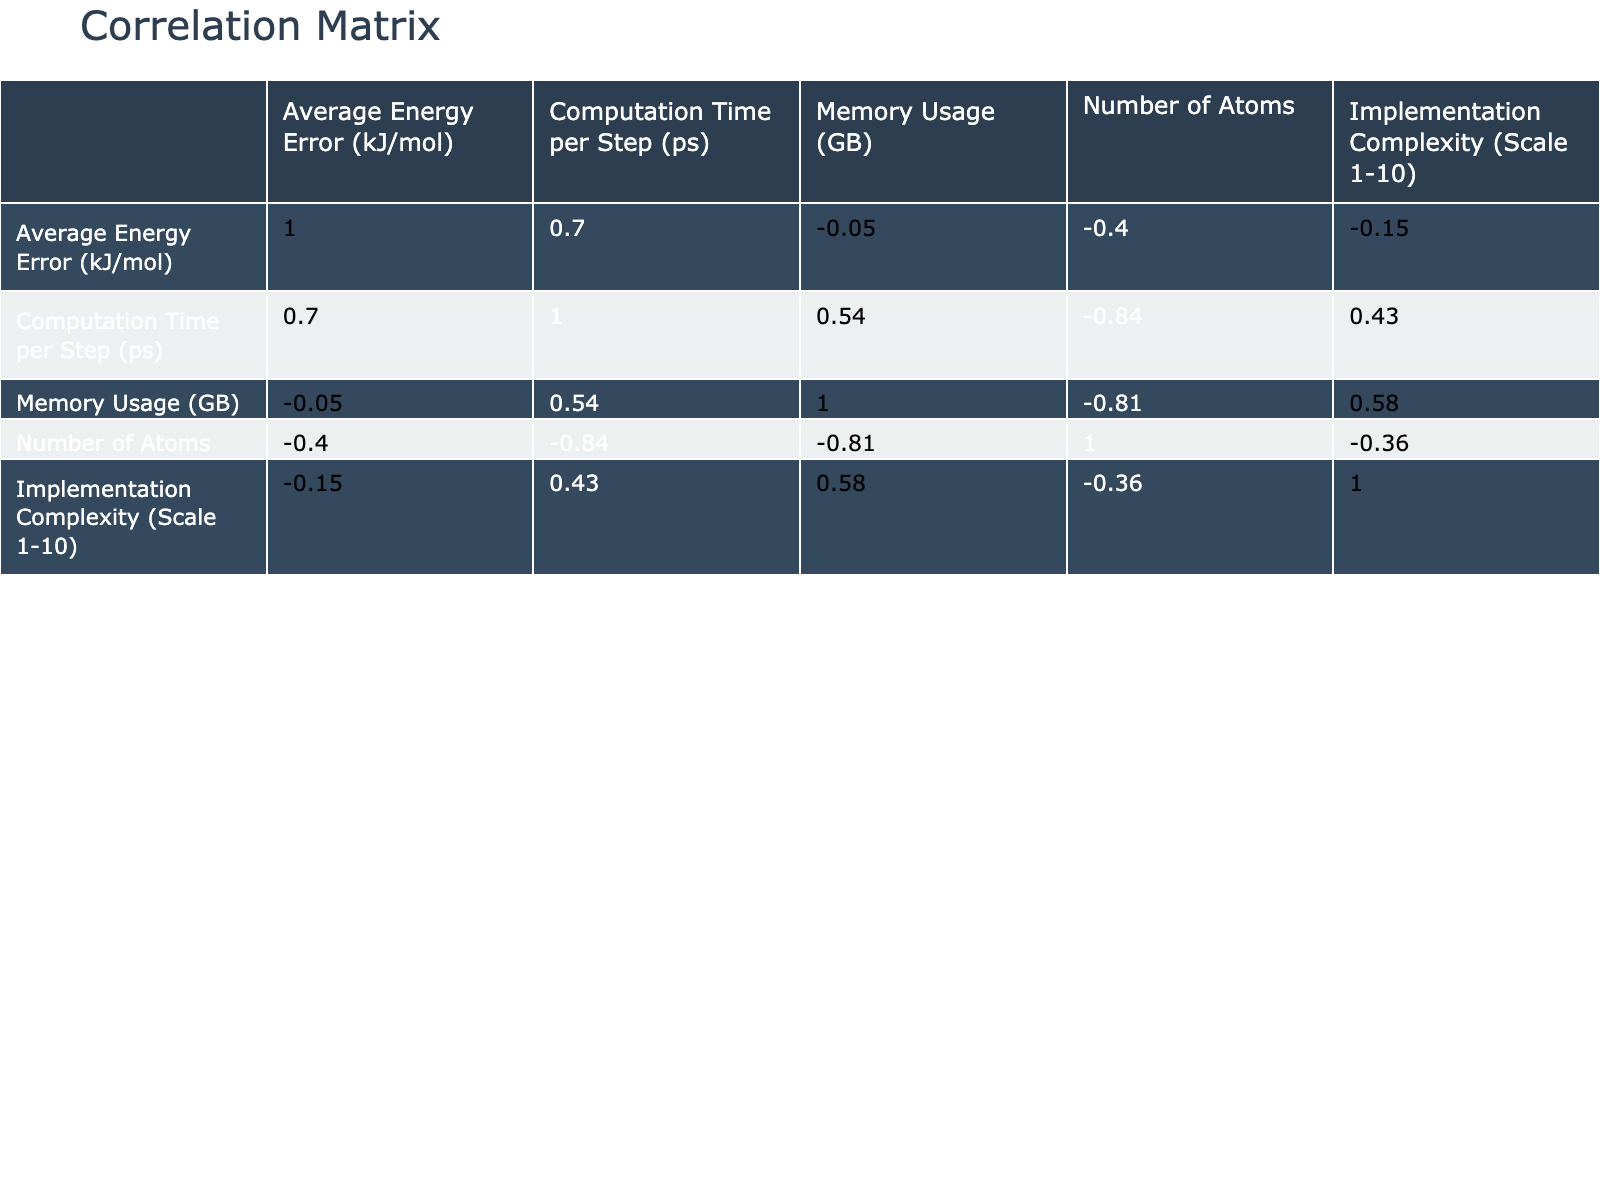What is the average energy error for DFT? From the table, we can directly look under the "Average Energy Error (kJ/mol)" column for the DFT method, which shows a value of 0.8.
Answer: 0.8 Which method has the highest memory usage? In the "Memory Usage (GB)" column, we can identify the maximum value by comparing all entries. The maximum value is 12.0, associated with the DFT method.
Answer: DFT What is the difference in computation time per step between CHARMM and OpenMM? We locate "Computation Time per Step (ps)" for CHARMM which is 0.003 and for OpenMM it is 0.0012. The difference is calculated as 0.003 - 0.0012, which equals 0.0018.
Answer: 0.0018 Which two methods have the lowest average energy error and what are their values? Looking at the "Average Energy Error (kJ/mol)" column, we find the two lowest values: GROMACS at 1.2 and DFT at 0.8. These correspond to the methods with the best error performance.
Answer: GROMACS (1.2), DFT (0.8) Is NAMD the most complex method according to the implementation complexity scale? To answer this, we check the "Implementation Complexity (Scale 1-10)" column and find NAMD has a score of 9, which is the highest among all methods listed.
Answer: Yes What is the average computational time per step across all methods? We sum the computation times from each method: 0.002 + 0.0015 + 0.003 + 0.002 + 0.004 + 0.0012 + 0.005 + 0.01 + 0.0045, which equals 0.0332. We then divide by the number of methods (9), yielding an average of approximately 0.00369.
Answer: 0.00369 Which method has the lowest energy error and how many atoms does it simulate? By scanning the "Average Energy Error (kJ/mol)", we see DFT has the lowest value of 0.8 and simulates 200 atoms as noted in the "Number of Atoms" column.
Answer: DFT (200 atoms) How many methods use more than 2 GB of memory? Checking the "Memory Usage (GB)", we find methods that exceed 2 GB: CHARMM (3.0), LAMMPS (2.5), NAMD (4.2), MSM (5.0), CASSCF (6.0), and DFT (12.0). There are six methods total that fit this criterion.
Answer: 6 Do methods with higher implementation complexity generally have lower energy error? Examining the correlation visually may suggest trends, but quantitative assessment would involve checking values. Notably, methods like CASSCF (complexity 9, error 3.0) and DFT (complexity 10, error 0.8) show higher complexity does not always lead to lower error.
Answer: No 